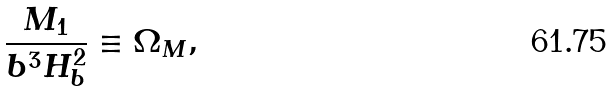<formula> <loc_0><loc_0><loc_500><loc_500>\frac { M _ { 1 } } { b ^ { 3 } H _ { b } ^ { 2 } } \equiv \Omega _ { M } ,</formula> 